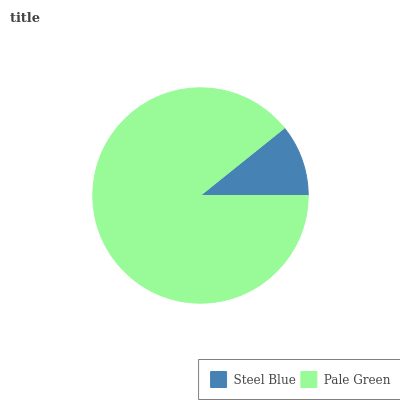Is Steel Blue the minimum?
Answer yes or no. Yes. Is Pale Green the maximum?
Answer yes or no. Yes. Is Pale Green the minimum?
Answer yes or no. No. Is Pale Green greater than Steel Blue?
Answer yes or no. Yes. Is Steel Blue less than Pale Green?
Answer yes or no. Yes. Is Steel Blue greater than Pale Green?
Answer yes or no. No. Is Pale Green less than Steel Blue?
Answer yes or no. No. Is Pale Green the high median?
Answer yes or no. Yes. Is Steel Blue the low median?
Answer yes or no. Yes. Is Steel Blue the high median?
Answer yes or no. No. Is Pale Green the low median?
Answer yes or no. No. 